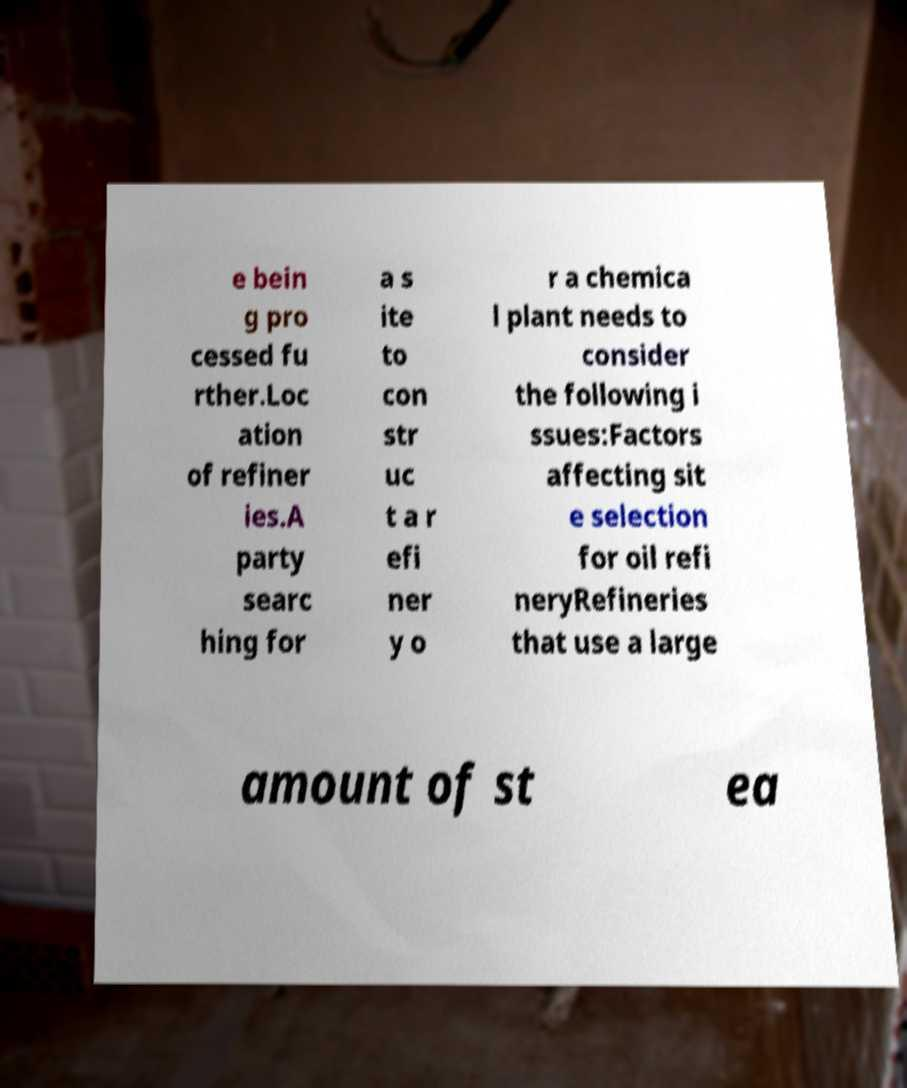Can you accurately transcribe the text from the provided image for me? e bein g pro cessed fu rther.Loc ation of refiner ies.A party searc hing for a s ite to con str uc t a r efi ner y o r a chemica l plant needs to consider the following i ssues:Factors affecting sit e selection for oil refi neryRefineries that use a large amount of st ea 